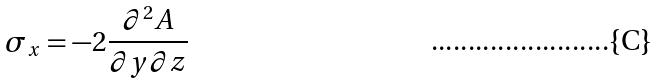<formula> <loc_0><loc_0><loc_500><loc_500>\sigma _ { x } = - 2 \frac { \partial ^ { 2 } A } { \partial y \partial z }</formula> 